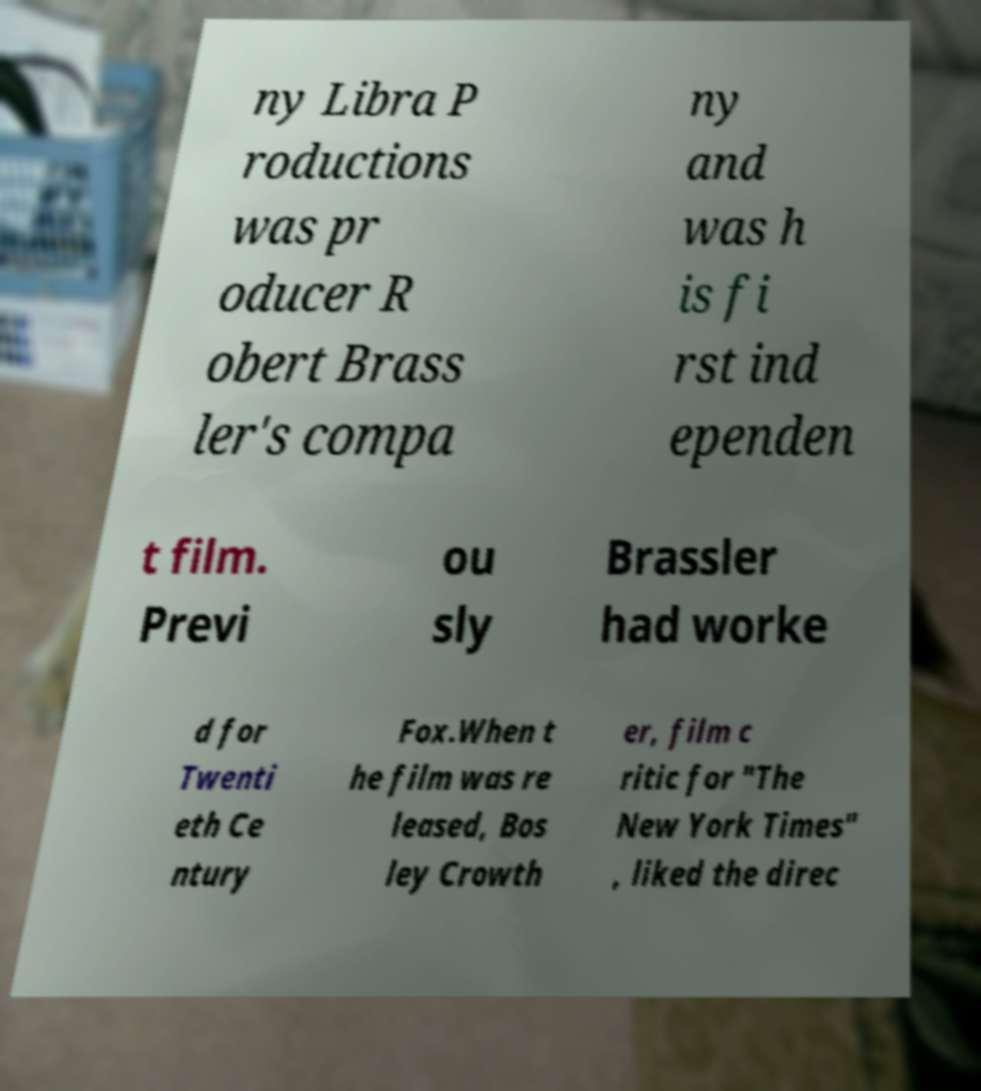What messages or text are displayed in this image? I need them in a readable, typed format. ny Libra P roductions was pr oducer R obert Brass ler's compa ny and was h is fi rst ind ependen t film. Previ ou sly Brassler had worke d for Twenti eth Ce ntury Fox.When t he film was re leased, Bos ley Crowth er, film c ritic for "The New York Times" , liked the direc 